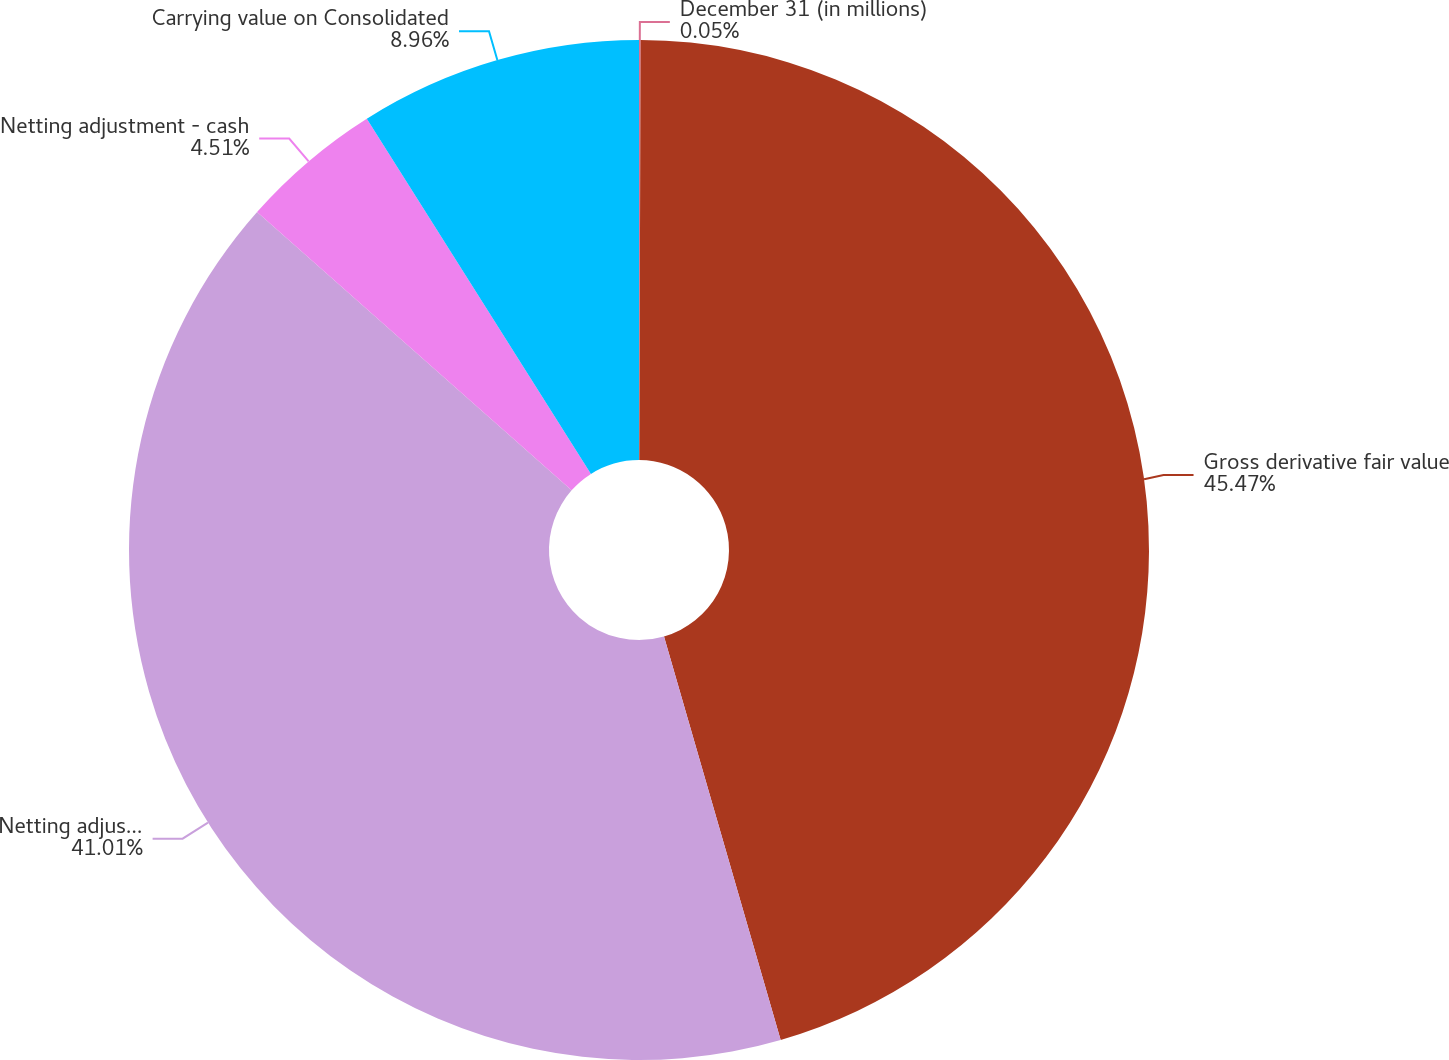Convert chart. <chart><loc_0><loc_0><loc_500><loc_500><pie_chart><fcel>December 31 (in millions)<fcel>Gross derivative fair value<fcel>Netting adjustment -<fcel>Netting adjustment - cash<fcel>Carrying value on Consolidated<nl><fcel>0.05%<fcel>45.47%<fcel>41.01%<fcel>4.51%<fcel>8.96%<nl></chart> 